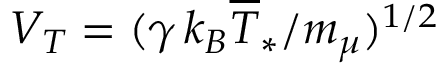<formula> <loc_0><loc_0><loc_500><loc_500>V _ { T } = ( \gamma \, k _ { B } \overline { T } _ { \ast } / m _ { \mu } ) ^ { 1 / 2 }</formula> 